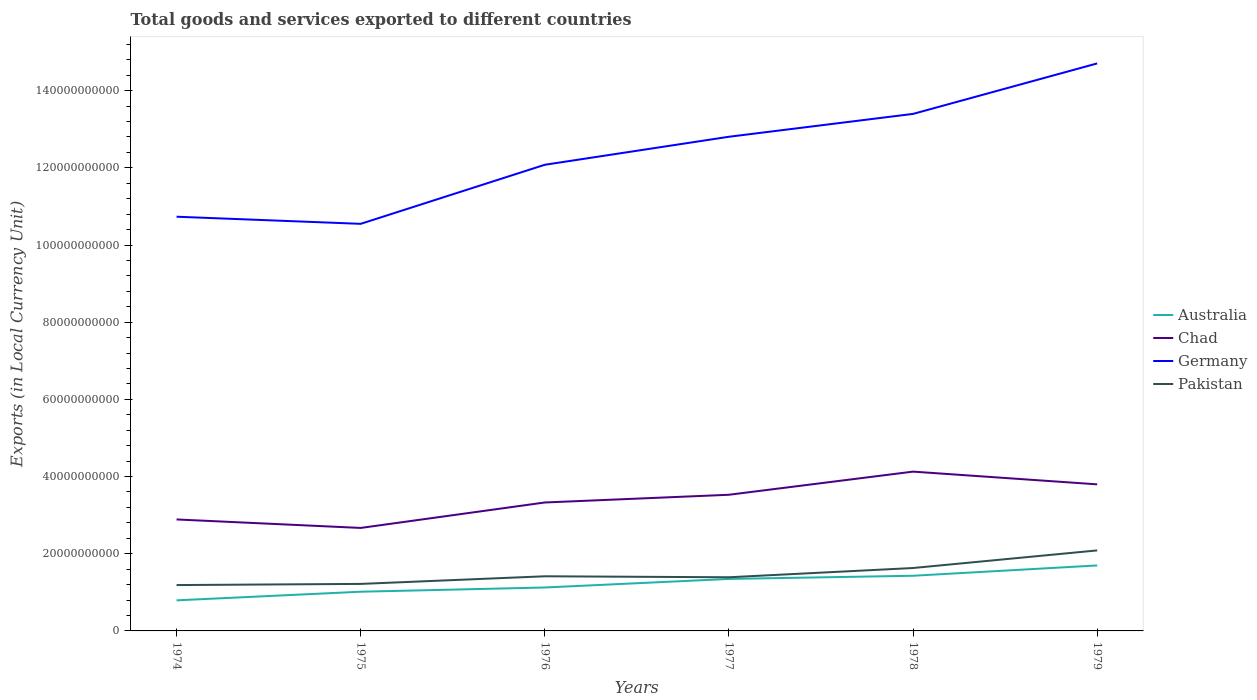Does the line corresponding to Pakistan intersect with the line corresponding to Germany?
Ensure brevity in your answer.  No. Across all years, what is the maximum Amount of goods and services exports in Chad?
Keep it short and to the point. 2.67e+1. In which year was the Amount of goods and services exports in Chad maximum?
Your response must be concise. 1975. What is the total Amount of goods and services exports in Australia in the graph?
Your answer should be very brief. -9.04e+09. What is the difference between the highest and the second highest Amount of goods and services exports in Germany?
Provide a succinct answer. 4.16e+1. What is the difference between the highest and the lowest Amount of goods and services exports in Germany?
Your answer should be very brief. 3. How many legend labels are there?
Offer a terse response. 4. How are the legend labels stacked?
Offer a terse response. Vertical. What is the title of the graph?
Make the answer very short. Total goods and services exported to different countries. Does "Uganda" appear as one of the legend labels in the graph?
Give a very brief answer. No. What is the label or title of the X-axis?
Provide a short and direct response. Years. What is the label or title of the Y-axis?
Provide a succinct answer. Exports (in Local Currency Unit). What is the Exports (in Local Currency Unit) in Australia in 1974?
Your response must be concise. 7.92e+09. What is the Exports (in Local Currency Unit) of Chad in 1974?
Your response must be concise. 2.89e+1. What is the Exports (in Local Currency Unit) of Germany in 1974?
Offer a very short reply. 1.07e+11. What is the Exports (in Local Currency Unit) in Pakistan in 1974?
Ensure brevity in your answer.  1.19e+1. What is the Exports (in Local Currency Unit) of Australia in 1975?
Make the answer very short. 1.02e+1. What is the Exports (in Local Currency Unit) of Chad in 1975?
Offer a very short reply. 2.67e+1. What is the Exports (in Local Currency Unit) in Germany in 1975?
Your answer should be very brief. 1.05e+11. What is the Exports (in Local Currency Unit) in Pakistan in 1975?
Ensure brevity in your answer.  1.22e+1. What is the Exports (in Local Currency Unit) in Australia in 1976?
Ensure brevity in your answer.  1.13e+1. What is the Exports (in Local Currency Unit) of Chad in 1976?
Make the answer very short. 3.33e+1. What is the Exports (in Local Currency Unit) in Germany in 1976?
Keep it short and to the point. 1.21e+11. What is the Exports (in Local Currency Unit) in Pakistan in 1976?
Provide a short and direct response. 1.42e+1. What is the Exports (in Local Currency Unit) in Australia in 1977?
Make the answer very short. 1.35e+1. What is the Exports (in Local Currency Unit) of Chad in 1977?
Offer a very short reply. 3.53e+1. What is the Exports (in Local Currency Unit) in Germany in 1977?
Offer a terse response. 1.28e+11. What is the Exports (in Local Currency Unit) of Pakistan in 1977?
Your response must be concise. 1.39e+1. What is the Exports (in Local Currency Unit) in Australia in 1978?
Ensure brevity in your answer.  1.43e+1. What is the Exports (in Local Currency Unit) of Chad in 1978?
Provide a short and direct response. 4.13e+1. What is the Exports (in Local Currency Unit) in Germany in 1978?
Make the answer very short. 1.34e+11. What is the Exports (in Local Currency Unit) of Pakistan in 1978?
Offer a terse response. 1.63e+1. What is the Exports (in Local Currency Unit) in Australia in 1979?
Keep it short and to the point. 1.70e+1. What is the Exports (in Local Currency Unit) in Chad in 1979?
Make the answer very short. 3.80e+1. What is the Exports (in Local Currency Unit) in Germany in 1979?
Offer a very short reply. 1.47e+11. What is the Exports (in Local Currency Unit) in Pakistan in 1979?
Offer a very short reply. 2.09e+1. Across all years, what is the maximum Exports (in Local Currency Unit) of Australia?
Offer a very short reply. 1.70e+1. Across all years, what is the maximum Exports (in Local Currency Unit) in Chad?
Ensure brevity in your answer.  4.13e+1. Across all years, what is the maximum Exports (in Local Currency Unit) of Germany?
Offer a terse response. 1.47e+11. Across all years, what is the maximum Exports (in Local Currency Unit) of Pakistan?
Your response must be concise. 2.09e+1. Across all years, what is the minimum Exports (in Local Currency Unit) of Australia?
Your answer should be very brief. 7.92e+09. Across all years, what is the minimum Exports (in Local Currency Unit) in Chad?
Offer a terse response. 2.67e+1. Across all years, what is the minimum Exports (in Local Currency Unit) in Germany?
Ensure brevity in your answer.  1.05e+11. Across all years, what is the minimum Exports (in Local Currency Unit) of Pakistan?
Offer a terse response. 1.19e+1. What is the total Exports (in Local Currency Unit) in Australia in the graph?
Offer a terse response. 7.41e+1. What is the total Exports (in Local Currency Unit) of Chad in the graph?
Your answer should be compact. 2.03e+11. What is the total Exports (in Local Currency Unit) in Germany in the graph?
Make the answer very short. 7.43e+11. What is the total Exports (in Local Currency Unit) in Pakistan in the graph?
Offer a terse response. 8.93e+1. What is the difference between the Exports (in Local Currency Unit) of Australia in 1974 and that in 1975?
Keep it short and to the point. -2.24e+09. What is the difference between the Exports (in Local Currency Unit) of Chad in 1974 and that in 1975?
Give a very brief answer. 2.20e+09. What is the difference between the Exports (in Local Currency Unit) of Germany in 1974 and that in 1975?
Provide a succinct answer. 1.84e+09. What is the difference between the Exports (in Local Currency Unit) of Pakistan in 1974 and that in 1975?
Your answer should be very brief. -3.03e+08. What is the difference between the Exports (in Local Currency Unit) of Australia in 1974 and that in 1976?
Offer a terse response. -3.33e+09. What is the difference between the Exports (in Local Currency Unit) in Chad in 1974 and that in 1976?
Your response must be concise. -4.40e+09. What is the difference between the Exports (in Local Currency Unit) of Germany in 1974 and that in 1976?
Offer a terse response. -1.35e+1. What is the difference between the Exports (in Local Currency Unit) of Pakistan in 1974 and that in 1976?
Give a very brief answer. -2.28e+09. What is the difference between the Exports (in Local Currency Unit) in Australia in 1974 and that in 1977?
Your response must be concise. -5.54e+09. What is the difference between the Exports (in Local Currency Unit) in Chad in 1974 and that in 1977?
Provide a succinct answer. -6.40e+09. What is the difference between the Exports (in Local Currency Unit) in Germany in 1974 and that in 1977?
Keep it short and to the point. -2.07e+1. What is the difference between the Exports (in Local Currency Unit) of Pakistan in 1974 and that in 1977?
Your answer should be very brief. -2.02e+09. What is the difference between the Exports (in Local Currency Unit) of Australia in 1974 and that in 1978?
Your response must be concise. -6.37e+09. What is the difference between the Exports (in Local Currency Unit) in Chad in 1974 and that in 1978?
Keep it short and to the point. -1.24e+1. What is the difference between the Exports (in Local Currency Unit) in Germany in 1974 and that in 1978?
Provide a succinct answer. -2.66e+1. What is the difference between the Exports (in Local Currency Unit) of Pakistan in 1974 and that in 1978?
Your response must be concise. -4.42e+09. What is the difference between the Exports (in Local Currency Unit) of Australia in 1974 and that in 1979?
Keep it short and to the point. -9.04e+09. What is the difference between the Exports (in Local Currency Unit) in Chad in 1974 and that in 1979?
Give a very brief answer. -9.10e+09. What is the difference between the Exports (in Local Currency Unit) in Germany in 1974 and that in 1979?
Offer a terse response. -3.97e+1. What is the difference between the Exports (in Local Currency Unit) of Pakistan in 1974 and that in 1979?
Provide a succinct answer. -8.98e+09. What is the difference between the Exports (in Local Currency Unit) of Australia in 1975 and that in 1976?
Ensure brevity in your answer.  -1.09e+09. What is the difference between the Exports (in Local Currency Unit) in Chad in 1975 and that in 1976?
Your answer should be very brief. -6.60e+09. What is the difference between the Exports (in Local Currency Unit) in Germany in 1975 and that in 1976?
Your response must be concise. -1.53e+1. What is the difference between the Exports (in Local Currency Unit) of Pakistan in 1975 and that in 1976?
Provide a succinct answer. -1.97e+09. What is the difference between the Exports (in Local Currency Unit) in Australia in 1975 and that in 1977?
Ensure brevity in your answer.  -3.31e+09. What is the difference between the Exports (in Local Currency Unit) of Chad in 1975 and that in 1977?
Provide a short and direct response. -8.60e+09. What is the difference between the Exports (in Local Currency Unit) of Germany in 1975 and that in 1977?
Ensure brevity in your answer.  -2.26e+1. What is the difference between the Exports (in Local Currency Unit) in Pakistan in 1975 and that in 1977?
Provide a succinct answer. -1.72e+09. What is the difference between the Exports (in Local Currency Unit) of Australia in 1975 and that in 1978?
Your response must be concise. -4.14e+09. What is the difference between the Exports (in Local Currency Unit) of Chad in 1975 and that in 1978?
Your answer should be compact. -1.46e+1. What is the difference between the Exports (in Local Currency Unit) in Germany in 1975 and that in 1978?
Give a very brief answer. -2.85e+1. What is the difference between the Exports (in Local Currency Unit) of Pakistan in 1975 and that in 1978?
Provide a succinct answer. -4.12e+09. What is the difference between the Exports (in Local Currency Unit) in Australia in 1975 and that in 1979?
Offer a terse response. -6.81e+09. What is the difference between the Exports (in Local Currency Unit) of Chad in 1975 and that in 1979?
Provide a short and direct response. -1.13e+1. What is the difference between the Exports (in Local Currency Unit) of Germany in 1975 and that in 1979?
Provide a short and direct response. -4.16e+1. What is the difference between the Exports (in Local Currency Unit) of Pakistan in 1975 and that in 1979?
Give a very brief answer. -8.68e+09. What is the difference between the Exports (in Local Currency Unit) of Australia in 1976 and that in 1977?
Your response must be concise. -2.22e+09. What is the difference between the Exports (in Local Currency Unit) in Chad in 1976 and that in 1977?
Your answer should be very brief. -2.00e+09. What is the difference between the Exports (in Local Currency Unit) in Germany in 1976 and that in 1977?
Your answer should be very brief. -7.26e+09. What is the difference between the Exports (in Local Currency Unit) in Pakistan in 1976 and that in 1977?
Your answer should be compact. 2.54e+08. What is the difference between the Exports (in Local Currency Unit) of Australia in 1976 and that in 1978?
Keep it short and to the point. -3.04e+09. What is the difference between the Exports (in Local Currency Unit) in Chad in 1976 and that in 1978?
Your response must be concise. -8.00e+09. What is the difference between the Exports (in Local Currency Unit) of Germany in 1976 and that in 1978?
Make the answer very short. -1.32e+1. What is the difference between the Exports (in Local Currency Unit) of Pakistan in 1976 and that in 1978?
Ensure brevity in your answer.  -2.14e+09. What is the difference between the Exports (in Local Currency Unit) of Australia in 1976 and that in 1979?
Offer a terse response. -5.72e+09. What is the difference between the Exports (in Local Currency Unit) of Chad in 1976 and that in 1979?
Provide a short and direct response. -4.70e+09. What is the difference between the Exports (in Local Currency Unit) in Germany in 1976 and that in 1979?
Your answer should be very brief. -2.63e+1. What is the difference between the Exports (in Local Currency Unit) in Pakistan in 1976 and that in 1979?
Keep it short and to the point. -6.70e+09. What is the difference between the Exports (in Local Currency Unit) of Australia in 1977 and that in 1978?
Provide a short and direct response. -8.26e+08. What is the difference between the Exports (in Local Currency Unit) in Chad in 1977 and that in 1978?
Your answer should be very brief. -6.00e+09. What is the difference between the Exports (in Local Currency Unit) of Germany in 1977 and that in 1978?
Offer a terse response. -5.92e+09. What is the difference between the Exports (in Local Currency Unit) of Pakistan in 1977 and that in 1978?
Provide a succinct answer. -2.40e+09. What is the difference between the Exports (in Local Currency Unit) in Australia in 1977 and that in 1979?
Make the answer very short. -3.50e+09. What is the difference between the Exports (in Local Currency Unit) in Chad in 1977 and that in 1979?
Give a very brief answer. -2.70e+09. What is the difference between the Exports (in Local Currency Unit) in Germany in 1977 and that in 1979?
Your answer should be very brief. -1.90e+1. What is the difference between the Exports (in Local Currency Unit) in Pakistan in 1977 and that in 1979?
Offer a terse response. -6.96e+09. What is the difference between the Exports (in Local Currency Unit) of Australia in 1978 and that in 1979?
Give a very brief answer. -2.67e+09. What is the difference between the Exports (in Local Currency Unit) of Chad in 1978 and that in 1979?
Keep it short and to the point. 3.30e+09. What is the difference between the Exports (in Local Currency Unit) of Germany in 1978 and that in 1979?
Your response must be concise. -1.31e+1. What is the difference between the Exports (in Local Currency Unit) in Pakistan in 1978 and that in 1979?
Offer a terse response. -4.56e+09. What is the difference between the Exports (in Local Currency Unit) of Australia in 1974 and the Exports (in Local Currency Unit) of Chad in 1975?
Your answer should be very brief. -1.88e+1. What is the difference between the Exports (in Local Currency Unit) of Australia in 1974 and the Exports (in Local Currency Unit) of Germany in 1975?
Make the answer very short. -9.76e+1. What is the difference between the Exports (in Local Currency Unit) in Australia in 1974 and the Exports (in Local Currency Unit) in Pakistan in 1975?
Keep it short and to the point. -4.26e+09. What is the difference between the Exports (in Local Currency Unit) of Chad in 1974 and the Exports (in Local Currency Unit) of Germany in 1975?
Give a very brief answer. -7.66e+1. What is the difference between the Exports (in Local Currency Unit) of Chad in 1974 and the Exports (in Local Currency Unit) of Pakistan in 1975?
Your answer should be very brief. 1.67e+1. What is the difference between the Exports (in Local Currency Unit) of Germany in 1974 and the Exports (in Local Currency Unit) of Pakistan in 1975?
Provide a short and direct response. 9.52e+1. What is the difference between the Exports (in Local Currency Unit) of Australia in 1974 and the Exports (in Local Currency Unit) of Chad in 1976?
Your response must be concise. -2.54e+1. What is the difference between the Exports (in Local Currency Unit) of Australia in 1974 and the Exports (in Local Currency Unit) of Germany in 1976?
Make the answer very short. -1.13e+11. What is the difference between the Exports (in Local Currency Unit) of Australia in 1974 and the Exports (in Local Currency Unit) of Pakistan in 1976?
Provide a succinct answer. -6.23e+09. What is the difference between the Exports (in Local Currency Unit) of Chad in 1974 and the Exports (in Local Currency Unit) of Germany in 1976?
Offer a terse response. -9.19e+1. What is the difference between the Exports (in Local Currency Unit) in Chad in 1974 and the Exports (in Local Currency Unit) in Pakistan in 1976?
Provide a short and direct response. 1.47e+1. What is the difference between the Exports (in Local Currency Unit) in Germany in 1974 and the Exports (in Local Currency Unit) in Pakistan in 1976?
Provide a short and direct response. 9.32e+1. What is the difference between the Exports (in Local Currency Unit) in Australia in 1974 and the Exports (in Local Currency Unit) in Chad in 1977?
Ensure brevity in your answer.  -2.74e+1. What is the difference between the Exports (in Local Currency Unit) of Australia in 1974 and the Exports (in Local Currency Unit) of Germany in 1977?
Your response must be concise. -1.20e+11. What is the difference between the Exports (in Local Currency Unit) in Australia in 1974 and the Exports (in Local Currency Unit) in Pakistan in 1977?
Offer a very short reply. -5.98e+09. What is the difference between the Exports (in Local Currency Unit) of Chad in 1974 and the Exports (in Local Currency Unit) of Germany in 1977?
Make the answer very short. -9.92e+1. What is the difference between the Exports (in Local Currency Unit) of Chad in 1974 and the Exports (in Local Currency Unit) of Pakistan in 1977?
Provide a short and direct response. 1.50e+1. What is the difference between the Exports (in Local Currency Unit) in Germany in 1974 and the Exports (in Local Currency Unit) in Pakistan in 1977?
Offer a terse response. 9.34e+1. What is the difference between the Exports (in Local Currency Unit) in Australia in 1974 and the Exports (in Local Currency Unit) in Chad in 1978?
Offer a very short reply. -3.34e+1. What is the difference between the Exports (in Local Currency Unit) of Australia in 1974 and the Exports (in Local Currency Unit) of Germany in 1978?
Your response must be concise. -1.26e+11. What is the difference between the Exports (in Local Currency Unit) in Australia in 1974 and the Exports (in Local Currency Unit) in Pakistan in 1978?
Make the answer very short. -8.38e+09. What is the difference between the Exports (in Local Currency Unit) in Chad in 1974 and the Exports (in Local Currency Unit) in Germany in 1978?
Provide a short and direct response. -1.05e+11. What is the difference between the Exports (in Local Currency Unit) of Chad in 1974 and the Exports (in Local Currency Unit) of Pakistan in 1978?
Keep it short and to the point. 1.26e+1. What is the difference between the Exports (in Local Currency Unit) in Germany in 1974 and the Exports (in Local Currency Unit) in Pakistan in 1978?
Your response must be concise. 9.10e+1. What is the difference between the Exports (in Local Currency Unit) of Australia in 1974 and the Exports (in Local Currency Unit) of Chad in 1979?
Make the answer very short. -3.01e+1. What is the difference between the Exports (in Local Currency Unit) in Australia in 1974 and the Exports (in Local Currency Unit) in Germany in 1979?
Keep it short and to the point. -1.39e+11. What is the difference between the Exports (in Local Currency Unit) of Australia in 1974 and the Exports (in Local Currency Unit) of Pakistan in 1979?
Your response must be concise. -1.29e+1. What is the difference between the Exports (in Local Currency Unit) in Chad in 1974 and the Exports (in Local Currency Unit) in Germany in 1979?
Give a very brief answer. -1.18e+11. What is the difference between the Exports (in Local Currency Unit) in Chad in 1974 and the Exports (in Local Currency Unit) in Pakistan in 1979?
Provide a short and direct response. 8.02e+09. What is the difference between the Exports (in Local Currency Unit) of Germany in 1974 and the Exports (in Local Currency Unit) of Pakistan in 1979?
Offer a terse response. 8.65e+1. What is the difference between the Exports (in Local Currency Unit) of Australia in 1975 and the Exports (in Local Currency Unit) of Chad in 1976?
Keep it short and to the point. -2.31e+1. What is the difference between the Exports (in Local Currency Unit) in Australia in 1975 and the Exports (in Local Currency Unit) in Germany in 1976?
Give a very brief answer. -1.11e+11. What is the difference between the Exports (in Local Currency Unit) in Australia in 1975 and the Exports (in Local Currency Unit) in Pakistan in 1976?
Your response must be concise. -4.00e+09. What is the difference between the Exports (in Local Currency Unit) in Chad in 1975 and the Exports (in Local Currency Unit) in Germany in 1976?
Your answer should be very brief. -9.41e+1. What is the difference between the Exports (in Local Currency Unit) of Chad in 1975 and the Exports (in Local Currency Unit) of Pakistan in 1976?
Offer a terse response. 1.25e+1. What is the difference between the Exports (in Local Currency Unit) of Germany in 1975 and the Exports (in Local Currency Unit) of Pakistan in 1976?
Your response must be concise. 9.13e+1. What is the difference between the Exports (in Local Currency Unit) of Australia in 1975 and the Exports (in Local Currency Unit) of Chad in 1977?
Give a very brief answer. -2.51e+1. What is the difference between the Exports (in Local Currency Unit) in Australia in 1975 and the Exports (in Local Currency Unit) in Germany in 1977?
Offer a very short reply. -1.18e+11. What is the difference between the Exports (in Local Currency Unit) in Australia in 1975 and the Exports (in Local Currency Unit) in Pakistan in 1977?
Your response must be concise. -3.74e+09. What is the difference between the Exports (in Local Currency Unit) of Chad in 1975 and the Exports (in Local Currency Unit) of Germany in 1977?
Your answer should be compact. -1.01e+11. What is the difference between the Exports (in Local Currency Unit) of Chad in 1975 and the Exports (in Local Currency Unit) of Pakistan in 1977?
Keep it short and to the point. 1.28e+1. What is the difference between the Exports (in Local Currency Unit) in Germany in 1975 and the Exports (in Local Currency Unit) in Pakistan in 1977?
Your answer should be compact. 9.16e+1. What is the difference between the Exports (in Local Currency Unit) of Australia in 1975 and the Exports (in Local Currency Unit) of Chad in 1978?
Make the answer very short. -3.11e+1. What is the difference between the Exports (in Local Currency Unit) in Australia in 1975 and the Exports (in Local Currency Unit) in Germany in 1978?
Offer a very short reply. -1.24e+11. What is the difference between the Exports (in Local Currency Unit) in Australia in 1975 and the Exports (in Local Currency Unit) in Pakistan in 1978?
Offer a terse response. -6.14e+09. What is the difference between the Exports (in Local Currency Unit) in Chad in 1975 and the Exports (in Local Currency Unit) in Germany in 1978?
Your response must be concise. -1.07e+11. What is the difference between the Exports (in Local Currency Unit) in Chad in 1975 and the Exports (in Local Currency Unit) in Pakistan in 1978?
Ensure brevity in your answer.  1.04e+1. What is the difference between the Exports (in Local Currency Unit) in Germany in 1975 and the Exports (in Local Currency Unit) in Pakistan in 1978?
Offer a very short reply. 8.92e+1. What is the difference between the Exports (in Local Currency Unit) in Australia in 1975 and the Exports (in Local Currency Unit) in Chad in 1979?
Offer a terse response. -2.78e+1. What is the difference between the Exports (in Local Currency Unit) of Australia in 1975 and the Exports (in Local Currency Unit) of Germany in 1979?
Your answer should be compact. -1.37e+11. What is the difference between the Exports (in Local Currency Unit) in Australia in 1975 and the Exports (in Local Currency Unit) in Pakistan in 1979?
Offer a terse response. -1.07e+1. What is the difference between the Exports (in Local Currency Unit) of Chad in 1975 and the Exports (in Local Currency Unit) of Germany in 1979?
Your answer should be compact. -1.20e+11. What is the difference between the Exports (in Local Currency Unit) of Chad in 1975 and the Exports (in Local Currency Unit) of Pakistan in 1979?
Your answer should be very brief. 5.83e+09. What is the difference between the Exports (in Local Currency Unit) in Germany in 1975 and the Exports (in Local Currency Unit) in Pakistan in 1979?
Your answer should be compact. 8.46e+1. What is the difference between the Exports (in Local Currency Unit) of Australia in 1976 and the Exports (in Local Currency Unit) of Chad in 1977?
Ensure brevity in your answer.  -2.40e+1. What is the difference between the Exports (in Local Currency Unit) of Australia in 1976 and the Exports (in Local Currency Unit) of Germany in 1977?
Make the answer very short. -1.17e+11. What is the difference between the Exports (in Local Currency Unit) in Australia in 1976 and the Exports (in Local Currency Unit) in Pakistan in 1977?
Offer a terse response. -2.65e+09. What is the difference between the Exports (in Local Currency Unit) in Chad in 1976 and the Exports (in Local Currency Unit) in Germany in 1977?
Your response must be concise. -9.48e+1. What is the difference between the Exports (in Local Currency Unit) of Chad in 1976 and the Exports (in Local Currency Unit) of Pakistan in 1977?
Offer a very short reply. 1.94e+1. What is the difference between the Exports (in Local Currency Unit) of Germany in 1976 and the Exports (in Local Currency Unit) of Pakistan in 1977?
Provide a succinct answer. 1.07e+11. What is the difference between the Exports (in Local Currency Unit) in Australia in 1976 and the Exports (in Local Currency Unit) in Chad in 1978?
Make the answer very short. -3.00e+1. What is the difference between the Exports (in Local Currency Unit) in Australia in 1976 and the Exports (in Local Currency Unit) in Germany in 1978?
Your response must be concise. -1.23e+11. What is the difference between the Exports (in Local Currency Unit) of Australia in 1976 and the Exports (in Local Currency Unit) of Pakistan in 1978?
Your answer should be very brief. -5.05e+09. What is the difference between the Exports (in Local Currency Unit) of Chad in 1976 and the Exports (in Local Currency Unit) of Germany in 1978?
Offer a terse response. -1.01e+11. What is the difference between the Exports (in Local Currency Unit) of Chad in 1976 and the Exports (in Local Currency Unit) of Pakistan in 1978?
Your answer should be compact. 1.70e+1. What is the difference between the Exports (in Local Currency Unit) in Germany in 1976 and the Exports (in Local Currency Unit) in Pakistan in 1978?
Your response must be concise. 1.04e+11. What is the difference between the Exports (in Local Currency Unit) in Australia in 1976 and the Exports (in Local Currency Unit) in Chad in 1979?
Keep it short and to the point. -2.67e+1. What is the difference between the Exports (in Local Currency Unit) of Australia in 1976 and the Exports (in Local Currency Unit) of Germany in 1979?
Your response must be concise. -1.36e+11. What is the difference between the Exports (in Local Currency Unit) in Australia in 1976 and the Exports (in Local Currency Unit) in Pakistan in 1979?
Your answer should be very brief. -9.61e+09. What is the difference between the Exports (in Local Currency Unit) of Chad in 1976 and the Exports (in Local Currency Unit) of Germany in 1979?
Ensure brevity in your answer.  -1.14e+11. What is the difference between the Exports (in Local Currency Unit) of Chad in 1976 and the Exports (in Local Currency Unit) of Pakistan in 1979?
Give a very brief answer. 1.24e+1. What is the difference between the Exports (in Local Currency Unit) in Germany in 1976 and the Exports (in Local Currency Unit) in Pakistan in 1979?
Ensure brevity in your answer.  9.99e+1. What is the difference between the Exports (in Local Currency Unit) of Australia in 1977 and the Exports (in Local Currency Unit) of Chad in 1978?
Provide a short and direct response. -2.78e+1. What is the difference between the Exports (in Local Currency Unit) in Australia in 1977 and the Exports (in Local Currency Unit) in Germany in 1978?
Your response must be concise. -1.21e+11. What is the difference between the Exports (in Local Currency Unit) in Australia in 1977 and the Exports (in Local Currency Unit) in Pakistan in 1978?
Provide a short and direct response. -2.83e+09. What is the difference between the Exports (in Local Currency Unit) in Chad in 1977 and the Exports (in Local Currency Unit) in Germany in 1978?
Provide a short and direct response. -9.87e+1. What is the difference between the Exports (in Local Currency Unit) in Chad in 1977 and the Exports (in Local Currency Unit) in Pakistan in 1978?
Offer a terse response. 1.90e+1. What is the difference between the Exports (in Local Currency Unit) in Germany in 1977 and the Exports (in Local Currency Unit) in Pakistan in 1978?
Keep it short and to the point. 1.12e+11. What is the difference between the Exports (in Local Currency Unit) of Australia in 1977 and the Exports (in Local Currency Unit) of Chad in 1979?
Your answer should be compact. -2.45e+1. What is the difference between the Exports (in Local Currency Unit) of Australia in 1977 and the Exports (in Local Currency Unit) of Germany in 1979?
Offer a very short reply. -1.34e+11. What is the difference between the Exports (in Local Currency Unit) of Australia in 1977 and the Exports (in Local Currency Unit) of Pakistan in 1979?
Ensure brevity in your answer.  -7.39e+09. What is the difference between the Exports (in Local Currency Unit) in Chad in 1977 and the Exports (in Local Currency Unit) in Germany in 1979?
Keep it short and to the point. -1.12e+11. What is the difference between the Exports (in Local Currency Unit) in Chad in 1977 and the Exports (in Local Currency Unit) in Pakistan in 1979?
Provide a short and direct response. 1.44e+1. What is the difference between the Exports (in Local Currency Unit) of Germany in 1977 and the Exports (in Local Currency Unit) of Pakistan in 1979?
Provide a succinct answer. 1.07e+11. What is the difference between the Exports (in Local Currency Unit) in Australia in 1978 and the Exports (in Local Currency Unit) in Chad in 1979?
Give a very brief answer. -2.37e+1. What is the difference between the Exports (in Local Currency Unit) in Australia in 1978 and the Exports (in Local Currency Unit) in Germany in 1979?
Offer a very short reply. -1.33e+11. What is the difference between the Exports (in Local Currency Unit) of Australia in 1978 and the Exports (in Local Currency Unit) of Pakistan in 1979?
Provide a short and direct response. -6.57e+09. What is the difference between the Exports (in Local Currency Unit) of Chad in 1978 and the Exports (in Local Currency Unit) of Germany in 1979?
Offer a very short reply. -1.06e+11. What is the difference between the Exports (in Local Currency Unit) of Chad in 1978 and the Exports (in Local Currency Unit) of Pakistan in 1979?
Provide a succinct answer. 2.04e+1. What is the difference between the Exports (in Local Currency Unit) in Germany in 1978 and the Exports (in Local Currency Unit) in Pakistan in 1979?
Offer a terse response. 1.13e+11. What is the average Exports (in Local Currency Unit) in Australia per year?
Give a very brief answer. 1.23e+1. What is the average Exports (in Local Currency Unit) of Chad per year?
Provide a short and direct response. 3.39e+1. What is the average Exports (in Local Currency Unit) of Germany per year?
Offer a terse response. 1.24e+11. What is the average Exports (in Local Currency Unit) of Pakistan per year?
Provide a short and direct response. 1.49e+1. In the year 1974, what is the difference between the Exports (in Local Currency Unit) of Australia and Exports (in Local Currency Unit) of Chad?
Ensure brevity in your answer.  -2.10e+1. In the year 1974, what is the difference between the Exports (in Local Currency Unit) in Australia and Exports (in Local Currency Unit) in Germany?
Offer a terse response. -9.94e+1. In the year 1974, what is the difference between the Exports (in Local Currency Unit) in Australia and Exports (in Local Currency Unit) in Pakistan?
Offer a terse response. -3.96e+09. In the year 1974, what is the difference between the Exports (in Local Currency Unit) of Chad and Exports (in Local Currency Unit) of Germany?
Your answer should be very brief. -7.84e+1. In the year 1974, what is the difference between the Exports (in Local Currency Unit) in Chad and Exports (in Local Currency Unit) in Pakistan?
Your answer should be very brief. 1.70e+1. In the year 1974, what is the difference between the Exports (in Local Currency Unit) in Germany and Exports (in Local Currency Unit) in Pakistan?
Offer a terse response. 9.55e+1. In the year 1975, what is the difference between the Exports (in Local Currency Unit) of Australia and Exports (in Local Currency Unit) of Chad?
Keep it short and to the point. -1.65e+1. In the year 1975, what is the difference between the Exports (in Local Currency Unit) of Australia and Exports (in Local Currency Unit) of Germany?
Provide a succinct answer. -9.53e+1. In the year 1975, what is the difference between the Exports (in Local Currency Unit) of Australia and Exports (in Local Currency Unit) of Pakistan?
Your answer should be very brief. -2.02e+09. In the year 1975, what is the difference between the Exports (in Local Currency Unit) of Chad and Exports (in Local Currency Unit) of Germany?
Your response must be concise. -7.88e+1. In the year 1975, what is the difference between the Exports (in Local Currency Unit) in Chad and Exports (in Local Currency Unit) in Pakistan?
Ensure brevity in your answer.  1.45e+1. In the year 1975, what is the difference between the Exports (in Local Currency Unit) of Germany and Exports (in Local Currency Unit) of Pakistan?
Make the answer very short. 9.33e+1. In the year 1976, what is the difference between the Exports (in Local Currency Unit) in Australia and Exports (in Local Currency Unit) in Chad?
Offer a terse response. -2.20e+1. In the year 1976, what is the difference between the Exports (in Local Currency Unit) in Australia and Exports (in Local Currency Unit) in Germany?
Offer a terse response. -1.10e+11. In the year 1976, what is the difference between the Exports (in Local Currency Unit) in Australia and Exports (in Local Currency Unit) in Pakistan?
Give a very brief answer. -2.90e+09. In the year 1976, what is the difference between the Exports (in Local Currency Unit) in Chad and Exports (in Local Currency Unit) in Germany?
Provide a short and direct response. -8.75e+1. In the year 1976, what is the difference between the Exports (in Local Currency Unit) in Chad and Exports (in Local Currency Unit) in Pakistan?
Your response must be concise. 1.91e+1. In the year 1976, what is the difference between the Exports (in Local Currency Unit) of Germany and Exports (in Local Currency Unit) of Pakistan?
Offer a terse response. 1.07e+11. In the year 1977, what is the difference between the Exports (in Local Currency Unit) of Australia and Exports (in Local Currency Unit) of Chad?
Your answer should be very brief. -2.18e+1. In the year 1977, what is the difference between the Exports (in Local Currency Unit) of Australia and Exports (in Local Currency Unit) of Germany?
Give a very brief answer. -1.15e+11. In the year 1977, what is the difference between the Exports (in Local Currency Unit) in Australia and Exports (in Local Currency Unit) in Pakistan?
Your answer should be compact. -4.35e+08. In the year 1977, what is the difference between the Exports (in Local Currency Unit) in Chad and Exports (in Local Currency Unit) in Germany?
Offer a terse response. -9.28e+1. In the year 1977, what is the difference between the Exports (in Local Currency Unit) in Chad and Exports (in Local Currency Unit) in Pakistan?
Ensure brevity in your answer.  2.14e+1. In the year 1977, what is the difference between the Exports (in Local Currency Unit) of Germany and Exports (in Local Currency Unit) of Pakistan?
Your answer should be very brief. 1.14e+11. In the year 1978, what is the difference between the Exports (in Local Currency Unit) in Australia and Exports (in Local Currency Unit) in Chad?
Provide a short and direct response. -2.70e+1. In the year 1978, what is the difference between the Exports (in Local Currency Unit) of Australia and Exports (in Local Currency Unit) of Germany?
Provide a succinct answer. -1.20e+11. In the year 1978, what is the difference between the Exports (in Local Currency Unit) of Australia and Exports (in Local Currency Unit) of Pakistan?
Your answer should be very brief. -2.01e+09. In the year 1978, what is the difference between the Exports (in Local Currency Unit) in Chad and Exports (in Local Currency Unit) in Germany?
Make the answer very short. -9.27e+1. In the year 1978, what is the difference between the Exports (in Local Currency Unit) of Chad and Exports (in Local Currency Unit) of Pakistan?
Provide a short and direct response. 2.50e+1. In the year 1978, what is the difference between the Exports (in Local Currency Unit) in Germany and Exports (in Local Currency Unit) in Pakistan?
Give a very brief answer. 1.18e+11. In the year 1979, what is the difference between the Exports (in Local Currency Unit) in Australia and Exports (in Local Currency Unit) in Chad?
Keep it short and to the point. -2.10e+1. In the year 1979, what is the difference between the Exports (in Local Currency Unit) in Australia and Exports (in Local Currency Unit) in Germany?
Your response must be concise. -1.30e+11. In the year 1979, what is the difference between the Exports (in Local Currency Unit) in Australia and Exports (in Local Currency Unit) in Pakistan?
Offer a very short reply. -3.89e+09. In the year 1979, what is the difference between the Exports (in Local Currency Unit) in Chad and Exports (in Local Currency Unit) in Germany?
Ensure brevity in your answer.  -1.09e+11. In the year 1979, what is the difference between the Exports (in Local Currency Unit) in Chad and Exports (in Local Currency Unit) in Pakistan?
Keep it short and to the point. 1.71e+1. In the year 1979, what is the difference between the Exports (in Local Currency Unit) of Germany and Exports (in Local Currency Unit) of Pakistan?
Offer a very short reply. 1.26e+11. What is the ratio of the Exports (in Local Currency Unit) of Australia in 1974 to that in 1975?
Make the answer very short. 0.78. What is the ratio of the Exports (in Local Currency Unit) of Chad in 1974 to that in 1975?
Your answer should be compact. 1.08. What is the ratio of the Exports (in Local Currency Unit) in Germany in 1974 to that in 1975?
Provide a succinct answer. 1.02. What is the ratio of the Exports (in Local Currency Unit) of Pakistan in 1974 to that in 1975?
Provide a succinct answer. 0.98. What is the ratio of the Exports (in Local Currency Unit) in Australia in 1974 to that in 1976?
Make the answer very short. 0.7. What is the ratio of the Exports (in Local Currency Unit) in Chad in 1974 to that in 1976?
Ensure brevity in your answer.  0.87. What is the ratio of the Exports (in Local Currency Unit) in Germany in 1974 to that in 1976?
Provide a succinct answer. 0.89. What is the ratio of the Exports (in Local Currency Unit) of Pakistan in 1974 to that in 1976?
Ensure brevity in your answer.  0.84. What is the ratio of the Exports (in Local Currency Unit) in Australia in 1974 to that in 1977?
Offer a terse response. 0.59. What is the ratio of the Exports (in Local Currency Unit) in Chad in 1974 to that in 1977?
Your response must be concise. 0.82. What is the ratio of the Exports (in Local Currency Unit) of Germany in 1974 to that in 1977?
Your response must be concise. 0.84. What is the ratio of the Exports (in Local Currency Unit) of Pakistan in 1974 to that in 1977?
Offer a terse response. 0.85. What is the ratio of the Exports (in Local Currency Unit) of Australia in 1974 to that in 1978?
Provide a short and direct response. 0.55. What is the ratio of the Exports (in Local Currency Unit) in Chad in 1974 to that in 1978?
Provide a succinct answer. 0.7. What is the ratio of the Exports (in Local Currency Unit) of Germany in 1974 to that in 1978?
Offer a terse response. 0.8. What is the ratio of the Exports (in Local Currency Unit) of Pakistan in 1974 to that in 1978?
Your answer should be compact. 0.73. What is the ratio of the Exports (in Local Currency Unit) in Australia in 1974 to that in 1979?
Ensure brevity in your answer.  0.47. What is the ratio of the Exports (in Local Currency Unit) in Chad in 1974 to that in 1979?
Provide a short and direct response. 0.76. What is the ratio of the Exports (in Local Currency Unit) in Germany in 1974 to that in 1979?
Ensure brevity in your answer.  0.73. What is the ratio of the Exports (in Local Currency Unit) in Pakistan in 1974 to that in 1979?
Ensure brevity in your answer.  0.57. What is the ratio of the Exports (in Local Currency Unit) of Australia in 1975 to that in 1976?
Your answer should be compact. 0.9. What is the ratio of the Exports (in Local Currency Unit) of Chad in 1975 to that in 1976?
Provide a short and direct response. 0.8. What is the ratio of the Exports (in Local Currency Unit) in Germany in 1975 to that in 1976?
Your answer should be compact. 0.87. What is the ratio of the Exports (in Local Currency Unit) in Pakistan in 1975 to that in 1976?
Make the answer very short. 0.86. What is the ratio of the Exports (in Local Currency Unit) in Australia in 1975 to that in 1977?
Your answer should be compact. 0.75. What is the ratio of the Exports (in Local Currency Unit) in Chad in 1975 to that in 1977?
Your answer should be compact. 0.76. What is the ratio of the Exports (in Local Currency Unit) in Germany in 1975 to that in 1977?
Provide a short and direct response. 0.82. What is the ratio of the Exports (in Local Currency Unit) of Pakistan in 1975 to that in 1977?
Offer a very short reply. 0.88. What is the ratio of the Exports (in Local Currency Unit) in Australia in 1975 to that in 1978?
Your response must be concise. 0.71. What is the ratio of the Exports (in Local Currency Unit) in Chad in 1975 to that in 1978?
Provide a short and direct response. 0.65. What is the ratio of the Exports (in Local Currency Unit) of Germany in 1975 to that in 1978?
Keep it short and to the point. 0.79. What is the ratio of the Exports (in Local Currency Unit) in Pakistan in 1975 to that in 1978?
Ensure brevity in your answer.  0.75. What is the ratio of the Exports (in Local Currency Unit) in Australia in 1975 to that in 1979?
Keep it short and to the point. 0.6. What is the ratio of the Exports (in Local Currency Unit) of Chad in 1975 to that in 1979?
Provide a short and direct response. 0.7. What is the ratio of the Exports (in Local Currency Unit) in Germany in 1975 to that in 1979?
Make the answer very short. 0.72. What is the ratio of the Exports (in Local Currency Unit) of Pakistan in 1975 to that in 1979?
Provide a short and direct response. 0.58. What is the ratio of the Exports (in Local Currency Unit) of Australia in 1976 to that in 1977?
Your answer should be very brief. 0.84. What is the ratio of the Exports (in Local Currency Unit) in Chad in 1976 to that in 1977?
Make the answer very short. 0.94. What is the ratio of the Exports (in Local Currency Unit) of Germany in 1976 to that in 1977?
Provide a short and direct response. 0.94. What is the ratio of the Exports (in Local Currency Unit) of Pakistan in 1976 to that in 1977?
Give a very brief answer. 1.02. What is the ratio of the Exports (in Local Currency Unit) of Australia in 1976 to that in 1978?
Keep it short and to the point. 0.79. What is the ratio of the Exports (in Local Currency Unit) in Chad in 1976 to that in 1978?
Make the answer very short. 0.81. What is the ratio of the Exports (in Local Currency Unit) in Germany in 1976 to that in 1978?
Give a very brief answer. 0.9. What is the ratio of the Exports (in Local Currency Unit) in Pakistan in 1976 to that in 1978?
Provide a short and direct response. 0.87. What is the ratio of the Exports (in Local Currency Unit) in Australia in 1976 to that in 1979?
Make the answer very short. 0.66. What is the ratio of the Exports (in Local Currency Unit) in Chad in 1976 to that in 1979?
Provide a succinct answer. 0.88. What is the ratio of the Exports (in Local Currency Unit) in Germany in 1976 to that in 1979?
Ensure brevity in your answer.  0.82. What is the ratio of the Exports (in Local Currency Unit) in Pakistan in 1976 to that in 1979?
Ensure brevity in your answer.  0.68. What is the ratio of the Exports (in Local Currency Unit) in Australia in 1977 to that in 1978?
Make the answer very short. 0.94. What is the ratio of the Exports (in Local Currency Unit) of Chad in 1977 to that in 1978?
Provide a short and direct response. 0.85. What is the ratio of the Exports (in Local Currency Unit) in Germany in 1977 to that in 1978?
Your answer should be very brief. 0.96. What is the ratio of the Exports (in Local Currency Unit) of Pakistan in 1977 to that in 1978?
Your answer should be compact. 0.85. What is the ratio of the Exports (in Local Currency Unit) in Australia in 1977 to that in 1979?
Provide a short and direct response. 0.79. What is the ratio of the Exports (in Local Currency Unit) in Chad in 1977 to that in 1979?
Provide a short and direct response. 0.93. What is the ratio of the Exports (in Local Currency Unit) of Germany in 1977 to that in 1979?
Offer a terse response. 0.87. What is the ratio of the Exports (in Local Currency Unit) of Pakistan in 1977 to that in 1979?
Ensure brevity in your answer.  0.67. What is the ratio of the Exports (in Local Currency Unit) of Australia in 1978 to that in 1979?
Offer a terse response. 0.84. What is the ratio of the Exports (in Local Currency Unit) in Chad in 1978 to that in 1979?
Offer a very short reply. 1.09. What is the ratio of the Exports (in Local Currency Unit) of Germany in 1978 to that in 1979?
Provide a short and direct response. 0.91. What is the ratio of the Exports (in Local Currency Unit) of Pakistan in 1978 to that in 1979?
Give a very brief answer. 0.78. What is the difference between the highest and the second highest Exports (in Local Currency Unit) of Australia?
Offer a very short reply. 2.67e+09. What is the difference between the highest and the second highest Exports (in Local Currency Unit) in Chad?
Offer a very short reply. 3.30e+09. What is the difference between the highest and the second highest Exports (in Local Currency Unit) of Germany?
Provide a succinct answer. 1.31e+1. What is the difference between the highest and the second highest Exports (in Local Currency Unit) of Pakistan?
Provide a succinct answer. 4.56e+09. What is the difference between the highest and the lowest Exports (in Local Currency Unit) in Australia?
Offer a very short reply. 9.04e+09. What is the difference between the highest and the lowest Exports (in Local Currency Unit) in Chad?
Keep it short and to the point. 1.46e+1. What is the difference between the highest and the lowest Exports (in Local Currency Unit) in Germany?
Offer a very short reply. 4.16e+1. What is the difference between the highest and the lowest Exports (in Local Currency Unit) of Pakistan?
Your answer should be very brief. 8.98e+09. 